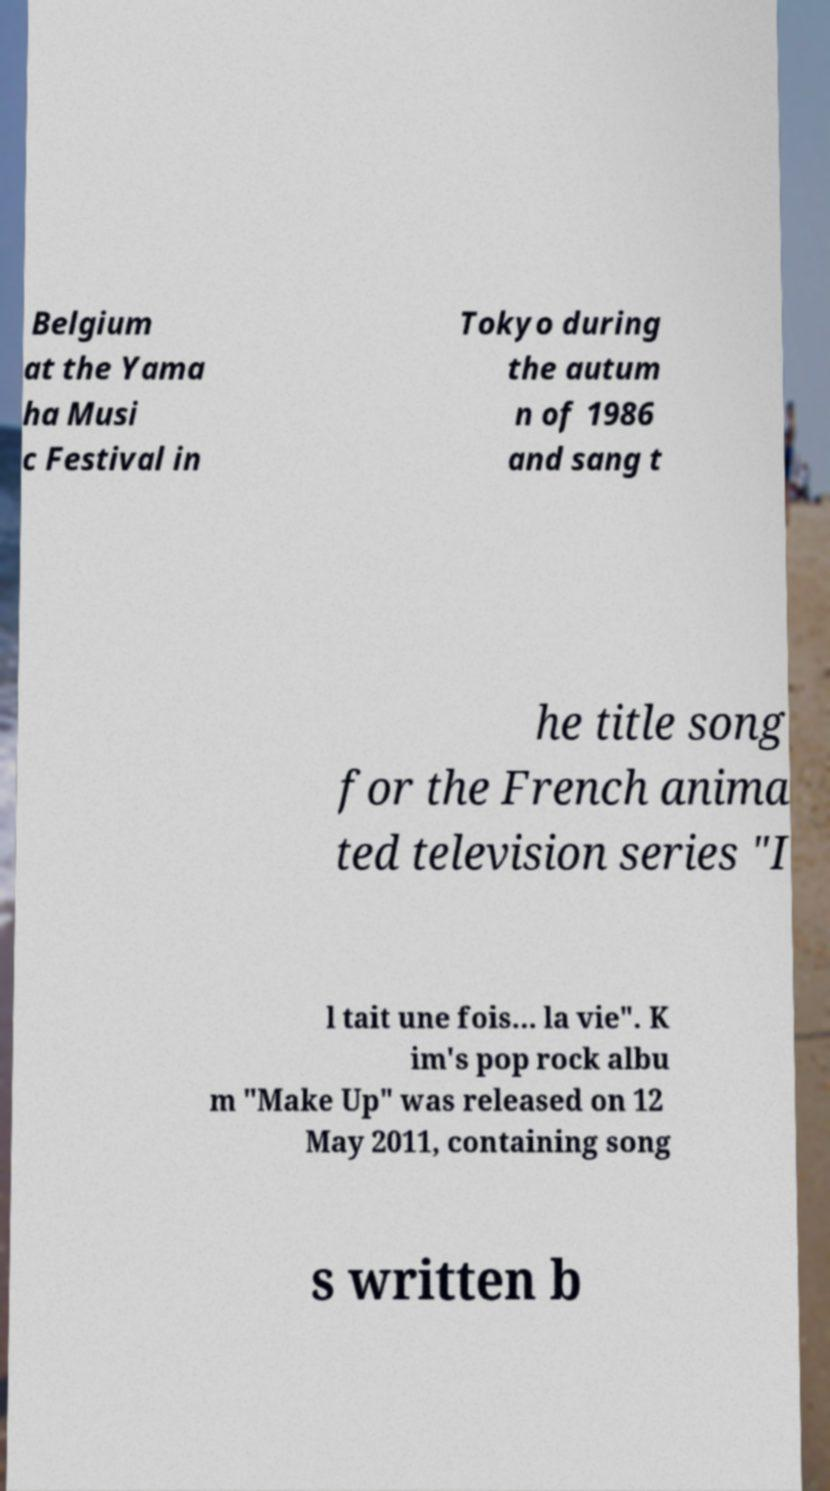For documentation purposes, I need the text within this image transcribed. Could you provide that? Belgium at the Yama ha Musi c Festival in Tokyo during the autum n of 1986 and sang t he title song for the French anima ted television series "I l tait une fois... la vie". K im's pop rock albu m "Make Up" was released on 12 May 2011, containing song s written b 